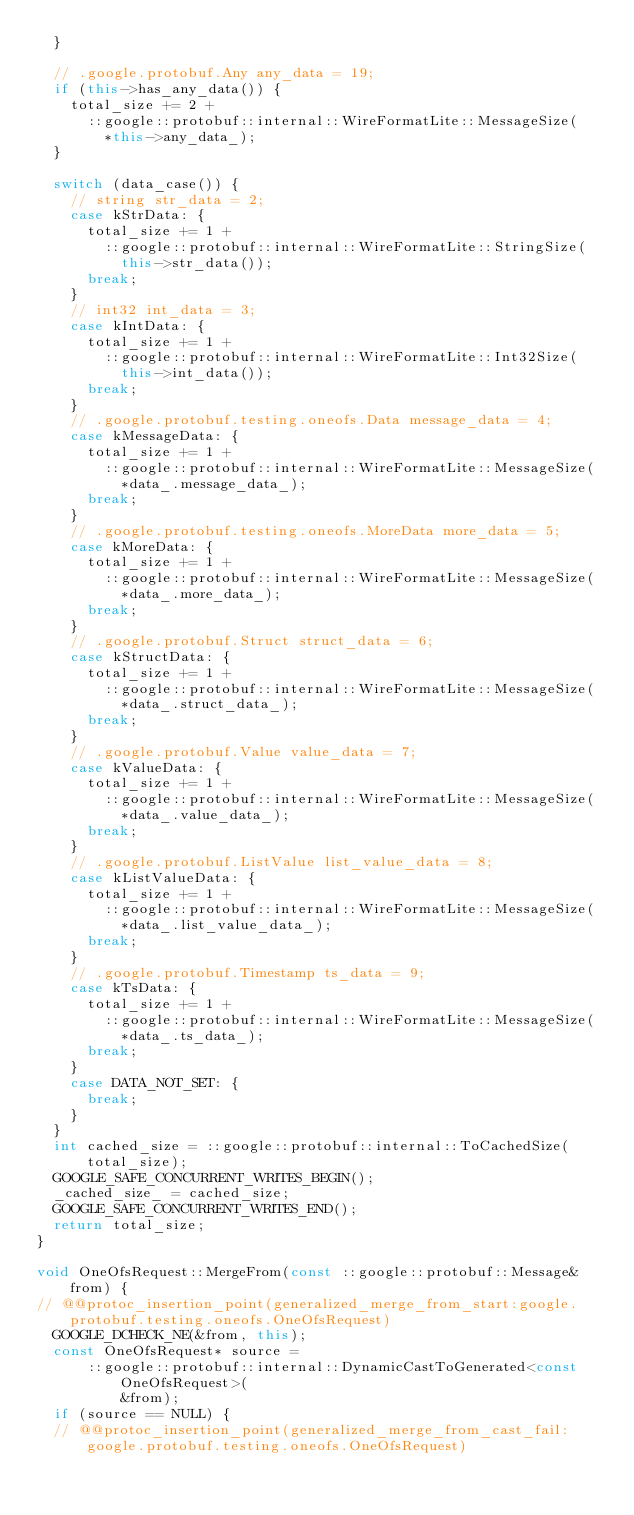<code> <loc_0><loc_0><loc_500><loc_500><_C++_>  }

  // .google.protobuf.Any any_data = 19;
  if (this->has_any_data()) {
    total_size += 2 +
      ::google::protobuf::internal::WireFormatLite::MessageSize(
        *this->any_data_);
  }

  switch (data_case()) {
    // string str_data = 2;
    case kStrData: {
      total_size += 1 +
        ::google::protobuf::internal::WireFormatLite::StringSize(
          this->str_data());
      break;
    }
    // int32 int_data = 3;
    case kIntData: {
      total_size += 1 +
        ::google::protobuf::internal::WireFormatLite::Int32Size(
          this->int_data());
      break;
    }
    // .google.protobuf.testing.oneofs.Data message_data = 4;
    case kMessageData: {
      total_size += 1 +
        ::google::protobuf::internal::WireFormatLite::MessageSize(
          *data_.message_data_);
      break;
    }
    // .google.protobuf.testing.oneofs.MoreData more_data = 5;
    case kMoreData: {
      total_size += 1 +
        ::google::protobuf::internal::WireFormatLite::MessageSize(
          *data_.more_data_);
      break;
    }
    // .google.protobuf.Struct struct_data = 6;
    case kStructData: {
      total_size += 1 +
        ::google::protobuf::internal::WireFormatLite::MessageSize(
          *data_.struct_data_);
      break;
    }
    // .google.protobuf.Value value_data = 7;
    case kValueData: {
      total_size += 1 +
        ::google::protobuf::internal::WireFormatLite::MessageSize(
          *data_.value_data_);
      break;
    }
    // .google.protobuf.ListValue list_value_data = 8;
    case kListValueData: {
      total_size += 1 +
        ::google::protobuf::internal::WireFormatLite::MessageSize(
          *data_.list_value_data_);
      break;
    }
    // .google.protobuf.Timestamp ts_data = 9;
    case kTsData: {
      total_size += 1 +
        ::google::protobuf::internal::WireFormatLite::MessageSize(
          *data_.ts_data_);
      break;
    }
    case DATA_NOT_SET: {
      break;
    }
  }
  int cached_size = ::google::protobuf::internal::ToCachedSize(total_size);
  GOOGLE_SAFE_CONCURRENT_WRITES_BEGIN();
  _cached_size_ = cached_size;
  GOOGLE_SAFE_CONCURRENT_WRITES_END();
  return total_size;
}

void OneOfsRequest::MergeFrom(const ::google::protobuf::Message& from) {
// @@protoc_insertion_point(generalized_merge_from_start:google.protobuf.testing.oneofs.OneOfsRequest)
  GOOGLE_DCHECK_NE(&from, this);
  const OneOfsRequest* source =
      ::google::protobuf::internal::DynamicCastToGenerated<const OneOfsRequest>(
          &from);
  if (source == NULL) {
  // @@protoc_insertion_point(generalized_merge_from_cast_fail:google.protobuf.testing.oneofs.OneOfsRequest)</code> 